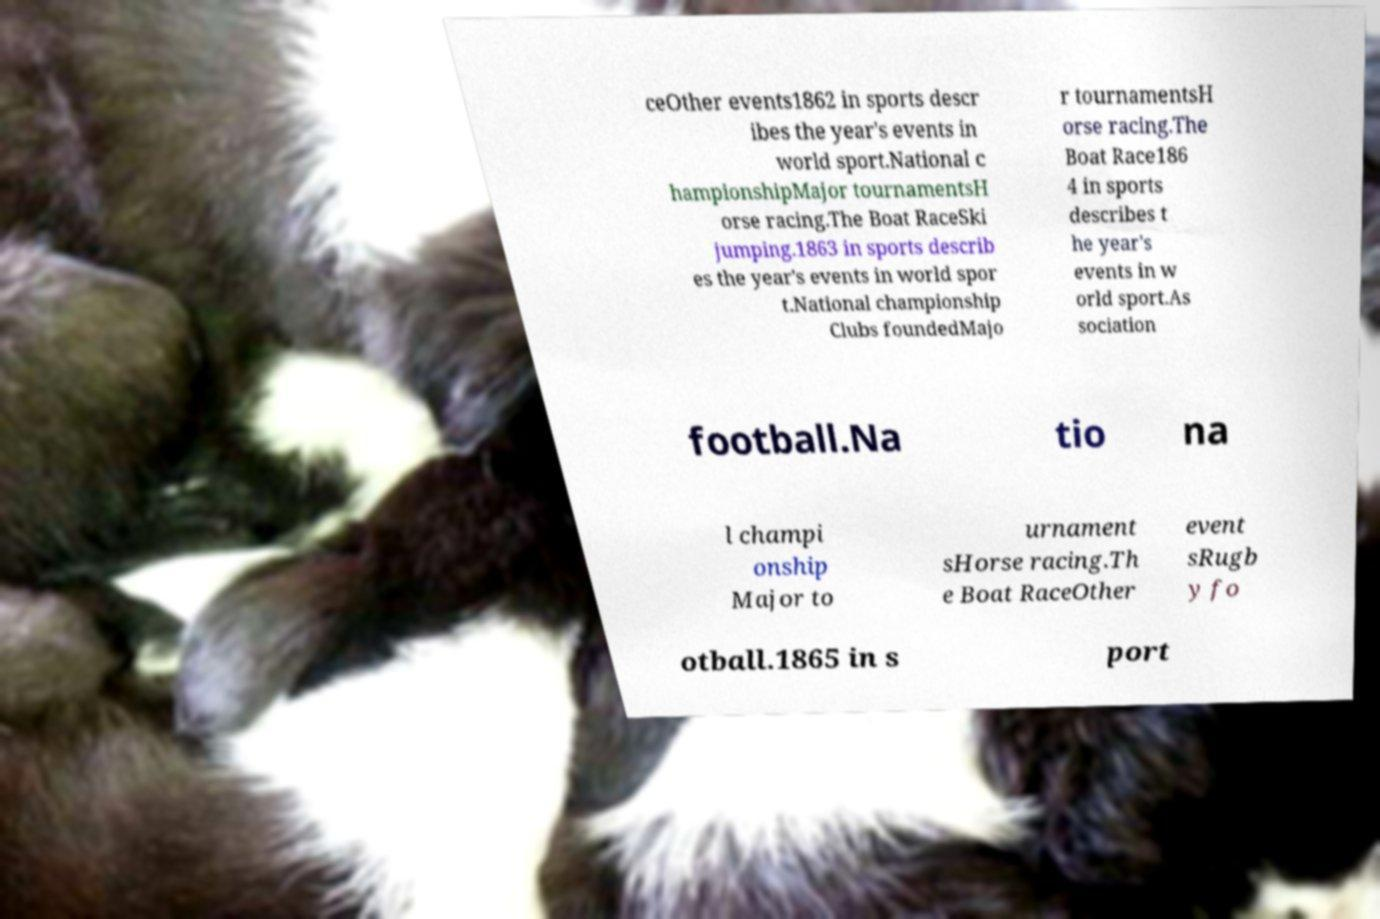Could you extract and type out the text from this image? ceOther events1862 in sports descr ibes the year's events in world sport.National c hampionshipMajor tournamentsH orse racing.The Boat RaceSki jumping.1863 in sports describ es the year's events in world spor t.National championship Clubs foundedMajo r tournamentsH orse racing.The Boat Race186 4 in sports describes t he year's events in w orld sport.As sociation football.Na tio na l champi onship Major to urnament sHorse racing.Th e Boat RaceOther event sRugb y fo otball.1865 in s port 